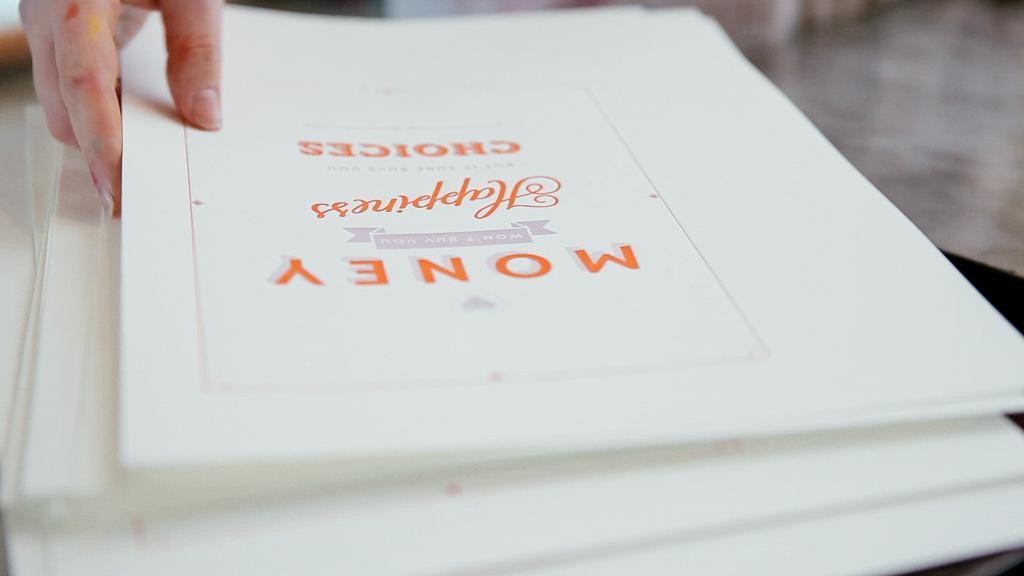Please provide a concise description of this image. There is a person touching a white color file which is on the other white color files which are on the table. In the background, there is floor. 